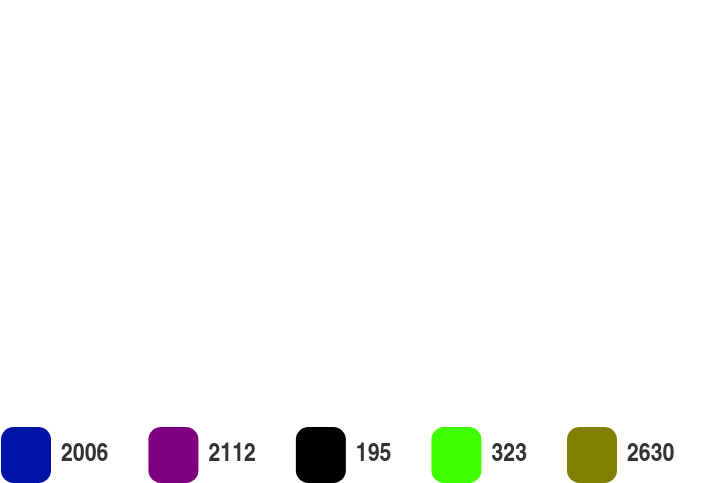Convert chart. <chart><loc_0><loc_0><loc_500><loc_500><pie_chart><fcel>2006<fcel>2112<fcel>195<fcel>323<fcel>2630<nl><fcel>60.91%<fcel>12.78%<fcel>0.75%<fcel>6.77%<fcel>18.8%<nl></chart> 